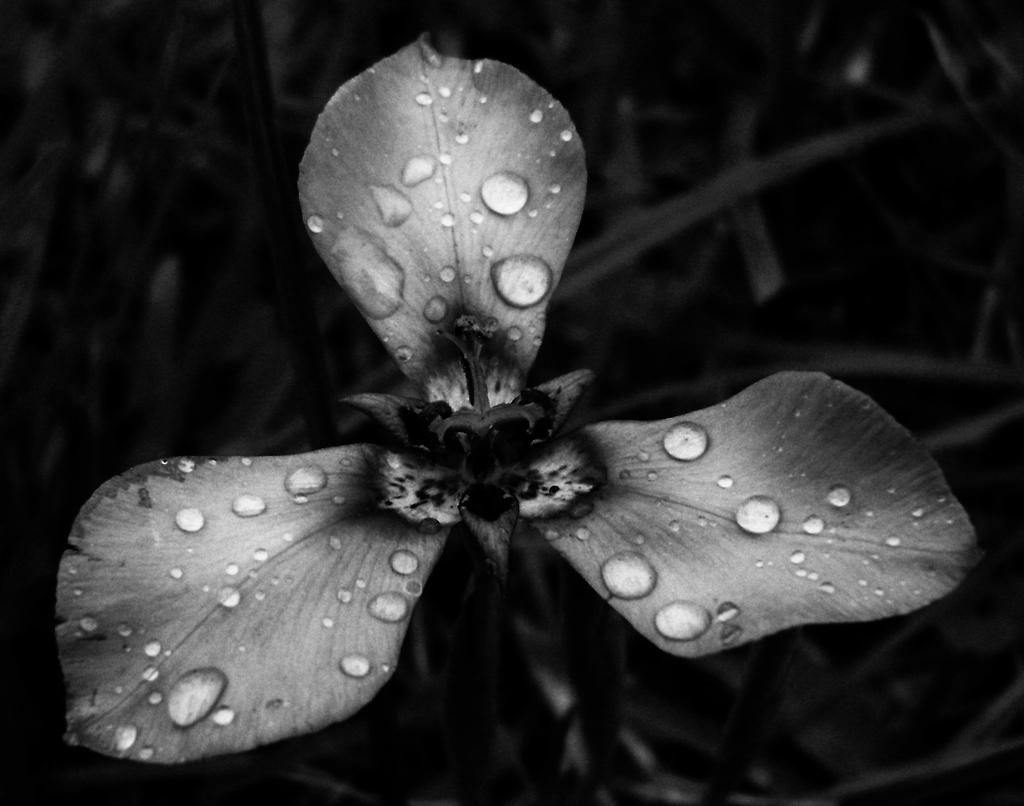What is the main subject of the image? There is a flower in the image. Can you describe the flower in the image? The flower has water drops on it. What can be seen in the background of the image? There are plants visible in the background of the image. How many houses are visible in the image? There are no houses present in the image; it features a flower with water drops and plants in the background. What type of design is featured on the bomb in the image? There is no bomb present in the image; it features a flower with water drops and plants in the background. 